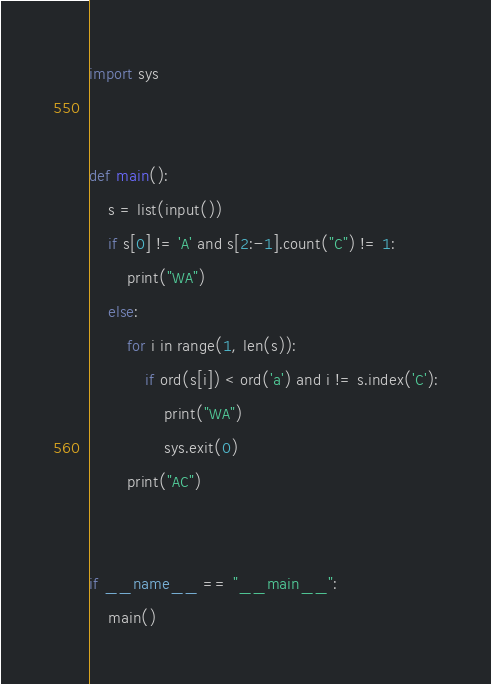<code> <loc_0><loc_0><loc_500><loc_500><_Python_>import sys


def main():
    s = list(input())
    if s[0] != 'A' and s[2:-1].count("C") != 1:
        print("WA")
    else:
        for i in range(1, len(s)):
            if ord(s[i]) < ord('a') and i != s.index('C'):
                print("WA")
                sys.exit(0)
        print("AC")


if __name__ == "__main__":
    main()
</code> 